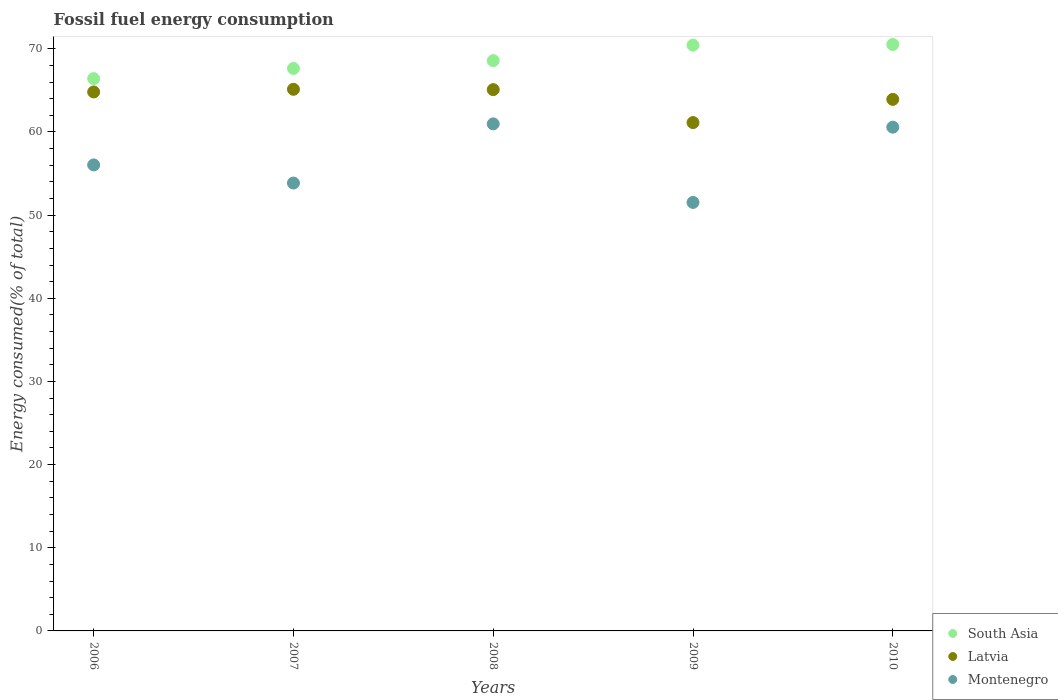What is the percentage of energy consumed in South Asia in 2006?
Give a very brief answer. 66.41. Across all years, what is the maximum percentage of energy consumed in Montenegro?
Your response must be concise. 60.97. Across all years, what is the minimum percentage of energy consumed in South Asia?
Your answer should be compact. 66.41. What is the total percentage of energy consumed in Montenegro in the graph?
Keep it short and to the point. 282.96. What is the difference between the percentage of energy consumed in Latvia in 2006 and that in 2009?
Your answer should be very brief. 3.68. What is the difference between the percentage of energy consumed in Latvia in 2010 and the percentage of energy consumed in South Asia in 2007?
Your answer should be very brief. -3.72. What is the average percentage of energy consumed in South Asia per year?
Make the answer very short. 68.72. In the year 2009, what is the difference between the percentage of energy consumed in South Asia and percentage of energy consumed in Latvia?
Make the answer very short. 9.31. What is the ratio of the percentage of energy consumed in Montenegro in 2007 to that in 2010?
Offer a very short reply. 0.89. Is the percentage of energy consumed in South Asia in 2009 less than that in 2010?
Your response must be concise. Yes. Is the difference between the percentage of energy consumed in South Asia in 2006 and 2007 greater than the difference between the percentage of energy consumed in Latvia in 2006 and 2007?
Provide a short and direct response. No. What is the difference between the highest and the second highest percentage of energy consumed in South Asia?
Offer a terse response. 0.08. What is the difference between the highest and the lowest percentage of energy consumed in Montenegro?
Ensure brevity in your answer.  9.44. Is the sum of the percentage of energy consumed in South Asia in 2006 and 2009 greater than the maximum percentage of energy consumed in Montenegro across all years?
Keep it short and to the point. Yes. Is the percentage of energy consumed in Latvia strictly greater than the percentage of energy consumed in Montenegro over the years?
Make the answer very short. Yes. Is the percentage of energy consumed in Montenegro strictly less than the percentage of energy consumed in Latvia over the years?
Provide a short and direct response. Yes. How many dotlines are there?
Your answer should be compact. 3. How many years are there in the graph?
Offer a terse response. 5. Are the values on the major ticks of Y-axis written in scientific E-notation?
Give a very brief answer. No. Does the graph contain grids?
Ensure brevity in your answer.  No. Where does the legend appear in the graph?
Your response must be concise. Bottom right. How many legend labels are there?
Make the answer very short. 3. What is the title of the graph?
Make the answer very short. Fossil fuel energy consumption. What is the label or title of the X-axis?
Keep it short and to the point. Years. What is the label or title of the Y-axis?
Your answer should be compact. Energy consumed(% of total). What is the Energy consumed(% of total) in South Asia in 2006?
Offer a very short reply. 66.41. What is the Energy consumed(% of total) of Latvia in 2006?
Offer a terse response. 64.81. What is the Energy consumed(% of total) of Montenegro in 2006?
Give a very brief answer. 56.03. What is the Energy consumed(% of total) in South Asia in 2007?
Your response must be concise. 67.63. What is the Energy consumed(% of total) of Latvia in 2007?
Give a very brief answer. 65.13. What is the Energy consumed(% of total) in Montenegro in 2007?
Give a very brief answer. 53.86. What is the Energy consumed(% of total) in South Asia in 2008?
Ensure brevity in your answer.  68.57. What is the Energy consumed(% of total) of Latvia in 2008?
Provide a short and direct response. 65.09. What is the Energy consumed(% of total) in Montenegro in 2008?
Provide a succinct answer. 60.97. What is the Energy consumed(% of total) of South Asia in 2009?
Give a very brief answer. 70.44. What is the Energy consumed(% of total) of Latvia in 2009?
Your answer should be compact. 61.13. What is the Energy consumed(% of total) in Montenegro in 2009?
Offer a very short reply. 51.53. What is the Energy consumed(% of total) in South Asia in 2010?
Ensure brevity in your answer.  70.52. What is the Energy consumed(% of total) in Latvia in 2010?
Give a very brief answer. 63.92. What is the Energy consumed(% of total) in Montenegro in 2010?
Your answer should be very brief. 60.58. Across all years, what is the maximum Energy consumed(% of total) of South Asia?
Provide a short and direct response. 70.52. Across all years, what is the maximum Energy consumed(% of total) in Latvia?
Ensure brevity in your answer.  65.13. Across all years, what is the maximum Energy consumed(% of total) of Montenegro?
Offer a very short reply. 60.97. Across all years, what is the minimum Energy consumed(% of total) of South Asia?
Your answer should be very brief. 66.41. Across all years, what is the minimum Energy consumed(% of total) in Latvia?
Make the answer very short. 61.13. Across all years, what is the minimum Energy consumed(% of total) in Montenegro?
Provide a short and direct response. 51.53. What is the total Energy consumed(% of total) of South Asia in the graph?
Offer a very short reply. 343.57. What is the total Energy consumed(% of total) of Latvia in the graph?
Offer a very short reply. 320.07. What is the total Energy consumed(% of total) in Montenegro in the graph?
Give a very brief answer. 282.96. What is the difference between the Energy consumed(% of total) in South Asia in 2006 and that in 2007?
Offer a very short reply. -1.22. What is the difference between the Energy consumed(% of total) of Latvia in 2006 and that in 2007?
Your answer should be very brief. -0.32. What is the difference between the Energy consumed(% of total) in Montenegro in 2006 and that in 2007?
Provide a short and direct response. 2.18. What is the difference between the Energy consumed(% of total) in South Asia in 2006 and that in 2008?
Offer a terse response. -2.16. What is the difference between the Energy consumed(% of total) in Latvia in 2006 and that in 2008?
Your answer should be very brief. -0.28. What is the difference between the Energy consumed(% of total) in Montenegro in 2006 and that in 2008?
Your answer should be very brief. -4.93. What is the difference between the Energy consumed(% of total) in South Asia in 2006 and that in 2009?
Provide a short and direct response. -4.03. What is the difference between the Energy consumed(% of total) of Latvia in 2006 and that in 2009?
Your response must be concise. 3.68. What is the difference between the Energy consumed(% of total) in Montenegro in 2006 and that in 2009?
Provide a short and direct response. 4.51. What is the difference between the Energy consumed(% of total) of South Asia in 2006 and that in 2010?
Your answer should be compact. -4.11. What is the difference between the Energy consumed(% of total) of Latvia in 2006 and that in 2010?
Provide a succinct answer. 0.89. What is the difference between the Energy consumed(% of total) of Montenegro in 2006 and that in 2010?
Make the answer very short. -4.54. What is the difference between the Energy consumed(% of total) in South Asia in 2007 and that in 2008?
Offer a terse response. -0.94. What is the difference between the Energy consumed(% of total) in Latvia in 2007 and that in 2008?
Your response must be concise. 0.04. What is the difference between the Energy consumed(% of total) of Montenegro in 2007 and that in 2008?
Your answer should be compact. -7.11. What is the difference between the Energy consumed(% of total) in South Asia in 2007 and that in 2009?
Your answer should be compact. -2.81. What is the difference between the Energy consumed(% of total) in Latvia in 2007 and that in 2009?
Offer a terse response. 4. What is the difference between the Energy consumed(% of total) of Montenegro in 2007 and that in 2009?
Keep it short and to the point. 2.33. What is the difference between the Energy consumed(% of total) in South Asia in 2007 and that in 2010?
Keep it short and to the point. -2.89. What is the difference between the Energy consumed(% of total) in Latvia in 2007 and that in 2010?
Provide a succinct answer. 1.21. What is the difference between the Energy consumed(% of total) in Montenegro in 2007 and that in 2010?
Give a very brief answer. -6.72. What is the difference between the Energy consumed(% of total) of South Asia in 2008 and that in 2009?
Your answer should be very brief. -1.86. What is the difference between the Energy consumed(% of total) of Latvia in 2008 and that in 2009?
Provide a short and direct response. 3.96. What is the difference between the Energy consumed(% of total) in Montenegro in 2008 and that in 2009?
Keep it short and to the point. 9.44. What is the difference between the Energy consumed(% of total) of South Asia in 2008 and that in 2010?
Keep it short and to the point. -1.95. What is the difference between the Energy consumed(% of total) of Latvia in 2008 and that in 2010?
Provide a short and direct response. 1.17. What is the difference between the Energy consumed(% of total) of Montenegro in 2008 and that in 2010?
Your answer should be compact. 0.39. What is the difference between the Energy consumed(% of total) in South Asia in 2009 and that in 2010?
Your response must be concise. -0.08. What is the difference between the Energy consumed(% of total) in Latvia in 2009 and that in 2010?
Offer a very short reply. -2.79. What is the difference between the Energy consumed(% of total) of Montenegro in 2009 and that in 2010?
Offer a very short reply. -9.05. What is the difference between the Energy consumed(% of total) of South Asia in 2006 and the Energy consumed(% of total) of Latvia in 2007?
Your answer should be compact. 1.28. What is the difference between the Energy consumed(% of total) in South Asia in 2006 and the Energy consumed(% of total) in Montenegro in 2007?
Offer a terse response. 12.56. What is the difference between the Energy consumed(% of total) in Latvia in 2006 and the Energy consumed(% of total) in Montenegro in 2007?
Give a very brief answer. 10.95. What is the difference between the Energy consumed(% of total) in South Asia in 2006 and the Energy consumed(% of total) in Latvia in 2008?
Offer a very short reply. 1.32. What is the difference between the Energy consumed(% of total) in South Asia in 2006 and the Energy consumed(% of total) in Montenegro in 2008?
Give a very brief answer. 5.44. What is the difference between the Energy consumed(% of total) of Latvia in 2006 and the Energy consumed(% of total) of Montenegro in 2008?
Your response must be concise. 3.84. What is the difference between the Energy consumed(% of total) of South Asia in 2006 and the Energy consumed(% of total) of Latvia in 2009?
Provide a short and direct response. 5.29. What is the difference between the Energy consumed(% of total) of South Asia in 2006 and the Energy consumed(% of total) of Montenegro in 2009?
Provide a short and direct response. 14.89. What is the difference between the Energy consumed(% of total) in Latvia in 2006 and the Energy consumed(% of total) in Montenegro in 2009?
Offer a very short reply. 13.28. What is the difference between the Energy consumed(% of total) in South Asia in 2006 and the Energy consumed(% of total) in Latvia in 2010?
Provide a succinct answer. 2.5. What is the difference between the Energy consumed(% of total) in South Asia in 2006 and the Energy consumed(% of total) in Montenegro in 2010?
Your answer should be very brief. 5.84. What is the difference between the Energy consumed(% of total) of Latvia in 2006 and the Energy consumed(% of total) of Montenegro in 2010?
Provide a succinct answer. 4.23. What is the difference between the Energy consumed(% of total) in South Asia in 2007 and the Energy consumed(% of total) in Latvia in 2008?
Give a very brief answer. 2.54. What is the difference between the Energy consumed(% of total) in South Asia in 2007 and the Energy consumed(% of total) in Montenegro in 2008?
Offer a terse response. 6.66. What is the difference between the Energy consumed(% of total) in Latvia in 2007 and the Energy consumed(% of total) in Montenegro in 2008?
Keep it short and to the point. 4.16. What is the difference between the Energy consumed(% of total) of South Asia in 2007 and the Energy consumed(% of total) of Latvia in 2009?
Offer a terse response. 6.51. What is the difference between the Energy consumed(% of total) of South Asia in 2007 and the Energy consumed(% of total) of Montenegro in 2009?
Make the answer very short. 16.11. What is the difference between the Energy consumed(% of total) in Latvia in 2007 and the Energy consumed(% of total) in Montenegro in 2009?
Give a very brief answer. 13.6. What is the difference between the Energy consumed(% of total) in South Asia in 2007 and the Energy consumed(% of total) in Latvia in 2010?
Your answer should be very brief. 3.72. What is the difference between the Energy consumed(% of total) of South Asia in 2007 and the Energy consumed(% of total) of Montenegro in 2010?
Ensure brevity in your answer.  7.06. What is the difference between the Energy consumed(% of total) of Latvia in 2007 and the Energy consumed(% of total) of Montenegro in 2010?
Give a very brief answer. 4.55. What is the difference between the Energy consumed(% of total) in South Asia in 2008 and the Energy consumed(% of total) in Latvia in 2009?
Ensure brevity in your answer.  7.45. What is the difference between the Energy consumed(% of total) in South Asia in 2008 and the Energy consumed(% of total) in Montenegro in 2009?
Provide a succinct answer. 17.05. What is the difference between the Energy consumed(% of total) in Latvia in 2008 and the Energy consumed(% of total) in Montenegro in 2009?
Ensure brevity in your answer.  13.56. What is the difference between the Energy consumed(% of total) of South Asia in 2008 and the Energy consumed(% of total) of Latvia in 2010?
Offer a terse response. 4.66. What is the difference between the Energy consumed(% of total) in South Asia in 2008 and the Energy consumed(% of total) in Montenegro in 2010?
Offer a terse response. 8. What is the difference between the Energy consumed(% of total) in Latvia in 2008 and the Energy consumed(% of total) in Montenegro in 2010?
Offer a terse response. 4.51. What is the difference between the Energy consumed(% of total) in South Asia in 2009 and the Energy consumed(% of total) in Latvia in 2010?
Keep it short and to the point. 6.52. What is the difference between the Energy consumed(% of total) in South Asia in 2009 and the Energy consumed(% of total) in Montenegro in 2010?
Offer a terse response. 9.86. What is the difference between the Energy consumed(% of total) of Latvia in 2009 and the Energy consumed(% of total) of Montenegro in 2010?
Keep it short and to the point. 0.55. What is the average Energy consumed(% of total) in South Asia per year?
Provide a succinct answer. 68.72. What is the average Energy consumed(% of total) in Latvia per year?
Provide a short and direct response. 64.01. What is the average Energy consumed(% of total) of Montenegro per year?
Your answer should be very brief. 56.59. In the year 2006, what is the difference between the Energy consumed(% of total) in South Asia and Energy consumed(% of total) in Latvia?
Provide a succinct answer. 1.6. In the year 2006, what is the difference between the Energy consumed(% of total) in South Asia and Energy consumed(% of total) in Montenegro?
Provide a succinct answer. 10.38. In the year 2006, what is the difference between the Energy consumed(% of total) in Latvia and Energy consumed(% of total) in Montenegro?
Provide a short and direct response. 8.77. In the year 2007, what is the difference between the Energy consumed(% of total) of South Asia and Energy consumed(% of total) of Latvia?
Make the answer very short. 2.5. In the year 2007, what is the difference between the Energy consumed(% of total) of South Asia and Energy consumed(% of total) of Montenegro?
Give a very brief answer. 13.78. In the year 2007, what is the difference between the Energy consumed(% of total) of Latvia and Energy consumed(% of total) of Montenegro?
Make the answer very short. 11.27. In the year 2008, what is the difference between the Energy consumed(% of total) in South Asia and Energy consumed(% of total) in Latvia?
Provide a short and direct response. 3.49. In the year 2008, what is the difference between the Energy consumed(% of total) in South Asia and Energy consumed(% of total) in Montenegro?
Ensure brevity in your answer.  7.6. In the year 2008, what is the difference between the Energy consumed(% of total) in Latvia and Energy consumed(% of total) in Montenegro?
Offer a very short reply. 4.12. In the year 2009, what is the difference between the Energy consumed(% of total) of South Asia and Energy consumed(% of total) of Latvia?
Your answer should be very brief. 9.31. In the year 2009, what is the difference between the Energy consumed(% of total) in South Asia and Energy consumed(% of total) in Montenegro?
Provide a short and direct response. 18.91. In the year 2009, what is the difference between the Energy consumed(% of total) in Latvia and Energy consumed(% of total) in Montenegro?
Offer a very short reply. 9.6. In the year 2010, what is the difference between the Energy consumed(% of total) in South Asia and Energy consumed(% of total) in Latvia?
Keep it short and to the point. 6.6. In the year 2010, what is the difference between the Energy consumed(% of total) in South Asia and Energy consumed(% of total) in Montenegro?
Your answer should be very brief. 9.94. In the year 2010, what is the difference between the Energy consumed(% of total) of Latvia and Energy consumed(% of total) of Montenegro?
Provide a short and direct response. 3.34. What is the ratio of the Energy consumed(% of total) of Montenegro in 2006 to that in 2007?
Make the answer very short. 1.04. What is the ratio of the Energy consumed(% of total) in South Asia in 2006 to that in 2008?
Keep it short and to the point. 0.97. What is the ratio of the Energy consumed(% of total) of Latvia in 2006 to that in 2008?
Your answer should be very brief. 1. What is the ratio of the Energy consumed(% of total) in Montenegro in 2006 to that in 2008?
Your answer should be very brief. 0.92. What is the ratio of the Energy consumed(% of total) in South Asia in 2006 to that in 2009?
Ensure brevity in your answer.  0.94. What is the ratio of the Energy consumed(% of total) in Latvia in 2006 to that in 2009?
Make the answer very short. 1.06. What is the ratio of the Energy consumed(% of total) in Montenegro in 2006 to that in 2009?
Your answer should be compact. 1.09. What is the ratio of the Energy consumed(% of total) in South Asia in 2006 to that in 2010?
Offer a terse response. 0.94. What is the ratio of the Energy consumed(% of total) in Latvia in 2006 to that in 2010?
Give a very brief answer. 1.01. What is the ratio of the Energy consumed(% of total) in Montenegro in 2006 to that in 2010?
Your response must be concise. 0.93. What is the ratio of the Energy consumed(% of total) in South Asia in 2007 to that in 2008?
Provide a short and direct response. 0.99. What is the ratio of the Energy consumed(% of total) of Latvia in 2007 to that in 2008?
Keep it short and to the point. 1. What is the ratio of the Energy consumed(% of total) in Montenegro in 2007 to that in 2008?
Your response must be concise. 0.88. What is the ratio of the Energy consumed(% of total) in South Asia in 2007 to that in 2009?
Offer a terse response. 0.96. What is the ratio of the Energy consumed(% of total) of Latvia in 2007 to that in 2009?
Make the answer very short. 1.07. What is the ratio of the Energy consumed(% of total) in Montenegro in 2007 to that in 2009?
Keep it short and to the point. 1.05. What is the ratio of the Energy consumed(% of total) in South Asia in 2007 to that in 2010?
Ensure brevity in your answer.  0.96. What is the ratio of the Energy consumed(% of total) of Montenegro in 2007 to that in 2010?
Keep it short and to the point. 0.89. What is the ratio of the Energy consumed(% of total) of South Asia in 2008 to that in 2009?
Your response must be concise. 0.97. What is the ratio of the Energy consumed(% of total) of Latvia in 2008 to that in 2009?
Your answer should be compact. 1.06. What is the ratio of the Energy consumed(% of total) of Montenegro in 2008 to that in 2009?
Your answer should be compact. 1.18. What is the ratio of the Energy consumed(% of total) in South Asia in 2008 to that in 2010?
Keep it short and to the point. 0.97. What is the ratio of the Energy consumed(% of total) of Latvia in 2008 to that in 2010?
Your response must be concise. 1.02. What is the ratio of the Energy consumed(% of total) of Montenegro in 2008 to that in 2010?
Provide a succinct answer. 1.01. What is the ratio of the Energy consumed(% of total) of South Asia in 2009 to that in 2010?
Make the answer very short. 1. What is the ratio of the Energy consumed(% of total) in Latvia in 2009 to that in 2010?
Your response must be concise. 0.96. What is the ratio of the Energy consumed(% of total) in Montenegro in 2009 to that in 2010?
Your response must be concise. 0.85. What is the difference between the highest and the second highest Energy consumed(% of total) in South Asia?
Your answer should be compact. 0.08. What is the difference between the highest and the second highest Energy consumed(% of total) in Latvia?
Give a very brief answer. 0.04. What is the difference between the highest and the second highest Energy consumed(% of total) in Montenegro?
Your answer should be very brief. 0.39. What is the difference between the highest and the lowest Energy consumed(% of total) in South Asia?
Keep it short and to the point. 4.11. What is the difference between the highest and the lowest Energy consumed(% of total) in Latvia?
Ensure brevity in your answer.  4. What is the difference between the highest and the lowest Energy consumed(% of total) in Montenegro?
Your answer should be very brief. 9.44. 